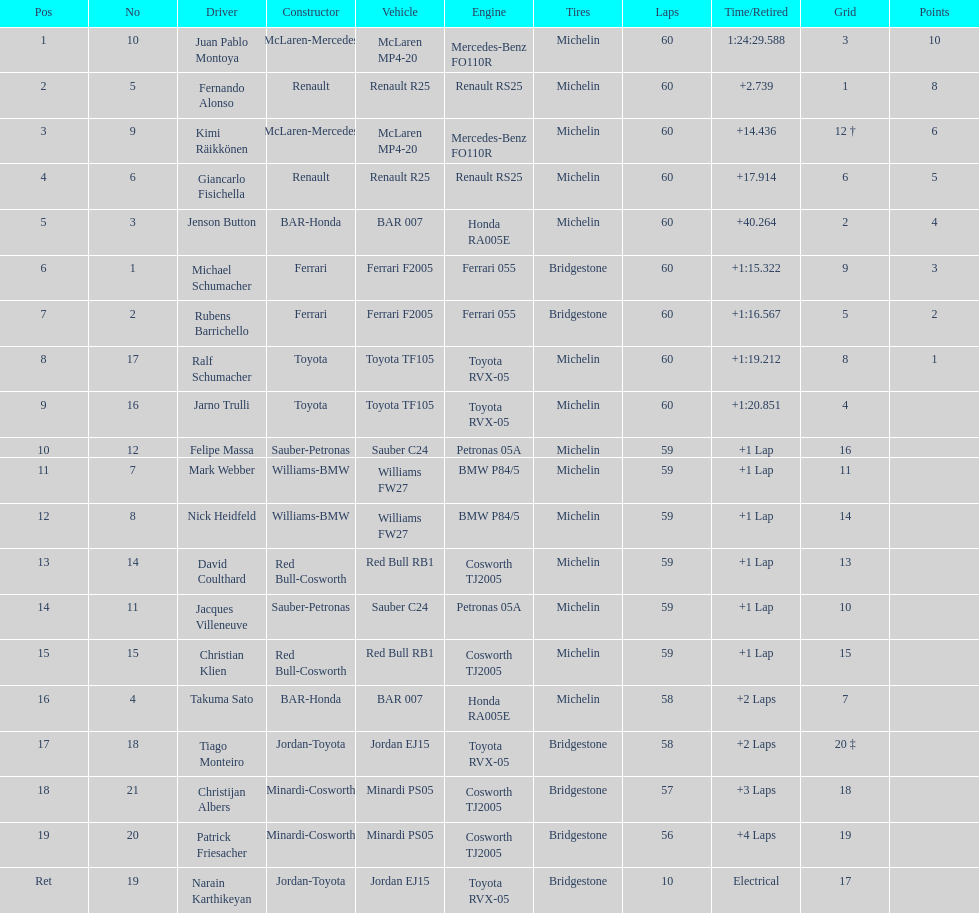What is the number of toyota's on the list? 4. Parse the full table. {'header': ['Pos', 'No', 'Driver', 'Constructor', 'Vehicle', 'Engine', 'Tires', 'Laps', 'Time/Retired', 'Grid', 'Points'], 'rows': [['1', '10', 'Juan Pablo Montoya', 'McLaren-Mercedes', 'McLaren MP4-20', 'Mercedes-Benz FO110R', 'Michelin', '60', '1:24:29.588', '3', '10'], ['2', '5', 'Fernando Alonso', 'Renault', 'Renault R25', 'Renault RS25', 'Michelin', '60', '+2.739', '1', '8'], ['3', '9', 'Kimi Räikkönen', 'McLaren-Mercedes', 'McLaren MP4-20', 'Mercedes-Benz FO110R', 'Michelin', '60', '+14.436', '12 †', '6'], ['4', '6', 'Giancarlo Fisichella', 'Renault', 'Renault R25', 'Renault RS25', 'Michelin', '60', '+17.914', '6', '5'], ['5', '3', 'Jenson Button', 'BAR-Honda', 'BAR 007', 'Honda RA005E', 'Michelin', '60', '+40.264', '2', '4'], ['6', '1', 'Michael Schumacher', 'Ferrari', 'Ferrari F2005', 'Ferrari 055', 'Bridgestone', '60', '+1:15.322', '9', '3'], ['7', '2', 'Rubens Barrichello', 'Ferrari', 'Ferrari F2005', 'Ferrari 055', 'Bridgestone', '60', '+1:16.567', '5', '2'], ['8', '17', 'Ralf Schumacher', 'Toyota', 'Toyota TF105', 'Toyota RVX-05', 'Michelin', '60', '+1:19.212', '8', '1'], ['9', '16', 'Jarno Trulli', 'Toyota', 'Toyota TF105', 'Toyota RVX-05', 'Michelin', '60', '+1:20.851', '4', ''], ['10', '12', 'Felipe Massa', 'Sauber-Petronas', 'Sauber C24', 'Petronas 05A', 'Michelin', '59', '+1 Lap', '16', ''], ['11', '7', 'Mark Webber', 'Williams-BMW', 'Williams FW27', 'BMW P84/5', 'Michelin', '59', '+1 Lap', '11', ''], ['12', '8', 'Nick Heidfeld', 'Williams-BMW', 'Williams FW27', 'BMW P84/5', 'Michelin', '59', '+1 Lap', '14', ''], ['13', '14', 'David Coulthard', 'Red Bull-Cosworth', 'Red Bull RB1', 'Cosworth TJ2005', 'Michelin', '59', '+1 Lap', '13', ''], ['14', '11', 'Jacques Villeneuve', 'Sauber-Petronas', 'Sauber C24', 'Petronas 05A', 'Michelin', '59', '+1 Lap', '10', ''], ['15', '15', 'Christian Klien', 'Red Bull-Cosworth', 'Red Bull RB1', 'Cosworth TJ2005', 'Michelin', '59', '+1 Lap', '15', ''], ['16', '4', 'Takuma Sato', 'BAR-Honda', 'BAR 007', 'Honda RA005E', 'Michelin', '58', '+2 Laps', '7', ''], ['17', '18', 'Tiago Monteiro', 'Jordan-Toyota', 'Jordan EJ15', 'Toyota RVX-05', 'Bridgestone', '58', '+2 Laps', '20 ‡', ''], ['18', '21', 'Christijan Albers', 'Minardi-Cosworth', 'Minardi PS05', 'Cosworth TJ2005', 'Bridgestone', '57', '+3 Laps', '18', ''], ['19', '20', 'Patrick Friesacher', 'Minardi-Cosworth', 'Minardi PS05', 'Cosworth TJ2005', 'Bridgestone', '56', '+4 Laps', '19', ''], ['Ret', '19', 'Narain Karthikeyan', 'Jordan-Toyota', 'Jordan EJ15', 'Toyota RVX-05', 'Bridgestone', '10', 'Electrical', '17', '']]} 